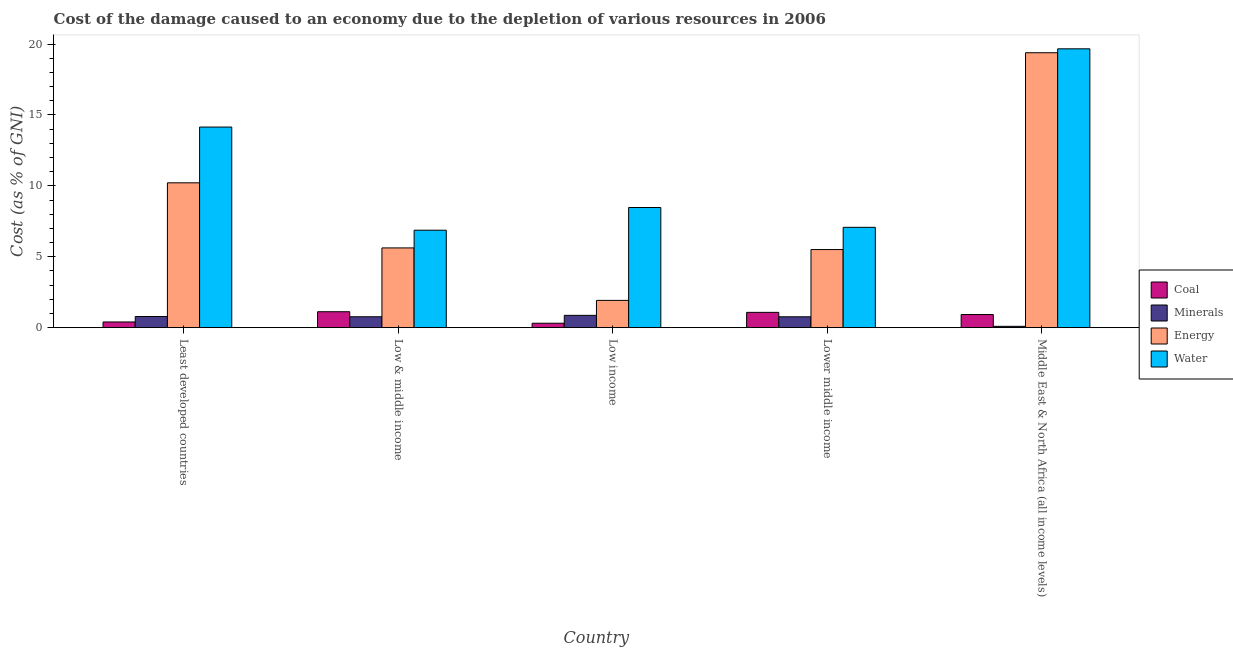How many different coloured bars are there?
Your answer should be compact. 4. How many bars are there on the 4th tick from the left?
Offer a terse response. 4. What is the label of the 4th group of bars from the left?
Your answer should be very brief. Lower middle income. What is the cost of damage due to depletion of energy in Low & middle income?
Keep it short and to the point. 5.62. Across all countries, what is the maximum cost of damage due to depletion of energy?
Your response must be concise. 19.39. Across all countries, what is the minimum cost of damage due to depletion of water?
Give a very brief answer. 6.87. What is the total cost of damage due to depletion of minerals in the graph?
Provide a succinct answer. 3.29. What is the difference between the cost of damage due to depletion of coal in Least developed countries and that in Low income?
Provide a short and direct response. 0.09. What is the difference between the cost of damage due to depletion of energy in Lower middle income and the cost of damage due to depletion of water in Low & middle income?
Give a very brief answer. -1.36. What is the average cost of damage due to depletion of energy per country?
Your response must be concise. 8.53. What is the difference between the cost of damage due to depletion of energy and cost of damage due to depletion of water in Least developed countries?
Your answer should be very brief. -3.93. In how many countries, is the cost of damage due to depletion of minerals greater than 5 %?
Your response must be concise. 0. What is the ratio of the cost of damage due to depletion of water in Lower middle income to that in Middle East & North Africa (all income levels)?
Give a very brief answer. 0.36. What is the difference between the highest and the second highest cost of damage due to depletion of minerals?
Provide a succinct answer. 0.08. What is the difference between the highest and the lowest cost of damage due to depletion of coal?
Your answer should be compact. 0.81. In how many countries, is the cost of damage due to depletion of minerals greater than the average cost of damage due to depletion of minerals taken over all countries?
Provide a succinct answer. 4. What does the 1st bar from the left in Least developed countries represents?
Make the answer very short. Coal. What does the 1st bar from the right in Lower middle income represents?
Your response must be concise. Water. Is it the case that in every country, the sum of the cost of damage due to depletion of coal and cost of damage due to depletion of minerals is greater than the cost of damage due to depletion of energy?
Ensure brevity in your answer.  No. How many countries are there in the graph?
Your answer should be very brief. 5. What is the difference between two consecutive major ticks on the Y-axis?
Offer a very short reply. 5. Does the graph contain any zero values?
Provide a short and direct response. No. Where does the legend appear in the graph?
Your answer should be very brief. Center right. How many legend labels are there?
Provide a short and direct response. 4. How are the legend labels stacked?
Your response must be concise. Vertical. What is the title of the graph?
Provide a short and direct response. Cost of the damage caused to an economy due to the depletion of various resources in 2006 . What is the label or title of the X-axis?
Offer a terse response. Country. What is the label or title of the Y-axis?
Provide a succinct answer. Cost (as % of GNI). What is the Cost (as % of GNI) of Coal in Least developed countries?
Your response must be concise. 0.4. What is the Cost (as % of GNI) in Minerals in Least developed countries?
Offer a very short reply. 0.79. What is the Cost (as % of GNI) in Energy in Least developed countries?
Give a very brief answer. 10.22. What is the Cost (as % of GNI) in Water in Least developed countries?
Give a very brief answer. 14.15. What is the Cost (as % of GNI) in Coal in Low & middle income?
Your answer should be compact. 1.12. What is the Cost (as % of GNI) of Minerals in Low & middle income?
Your response must be concise. 0.77. What is the Cost (as % of GNI) of Energy in Low & middle income?
Offer a terse response. 5.62. What is the Cost (as % of GNI) in Water in Low & middle income?
Keep it short and to the point. 6.87. What is the Cost (as % of GNI) of Coal in Low income?
Offer a terse response. 0.31. What is the Cost (as % of GNI) of Minerals in Low income?
Offer a very short reply. 0.87. What is the Cost (as % of GNI) in Energy in Low income?
Your answer should be very brief. 1.92. What is the Cost (as % of GNI) of Water in Low income?
Offer a terse response. 8.47. What is the Cost (as % of GNI) of Coal in Lower middle income?
Your answer should be compact. 1.08. What is the Cost (as % of GNI) in Minerals in Lower middle income?
Your answer should be compact. 0.77. What is the Cost (as % of GNI) of Energy in Lower middle income?
Your answer should be compact. 5.51. What is the Cost (as % of GNI) of Water in Lower middle income?
Make the answer very short. 7.08. What is the Cost (as % of GNI) in Coal in Middle East & North Africa (all income levels)?
Your response must be concise. 0.93. What is the Cost (as % of GNI) of Minerals in Middle East & North Africa (all income levels)?
Offer a very short reply. 0.09. What is the Cost (as % of GNI) in Energy in Middle East & North Africa (all income levels)?
Offer a terse response. 19.39. What is the Cost (as % of GNI) in Water in Middle East & North Africa (all income levels)?
Provide a short and direct response. 19.67. Across all countries, what is the maximum Cost (as % of GNI) in Coal?
Provide a short and direct response. 1.12. Across all countries, what is the maximum Cost (as % of GNI) of Minerals?
Your answer should be compact. 0.87. Across all countries, what is the maximum Cost (as % of GNI) in Energy?
Ensure brevity in your answer.  19.39. Across all countries, what is the maximum Cost (as % of GNI) in Water?
Your answer should be compact. 19.67. Across all countries, what is the minimum Cost (as % of GNI) of Coal?
Provide a short and direct response. 0.31. Across all countries, what is the minimum Cost (as % of GNI) in Minerals?
Keep it short and to the point. 0.09. Across all countries, what is the minimum Cost (as % of GNI) in Energy?
Your answer should be compact. 1.92. Across all countries, what is the minimum Cost (as % of GNI) of Water?
Give a very brief answer. 6.87. What is the total Cost (as % of GNI) of Coal in the graph?
Provide a succinct answer. 3.84. What is the total Cost (as % of GNI) in Minerals in the graph?
Keep it short and to the point. 3.29. What is the total Cost (as % of GNI) in Energy in the graph?
Your response must be concise. 42.66. What is the total Cost (as % of GNI) in Water in the graph?
Offer a terse response. 56.24. What is the difference between the Cost (as % of GNI) in Coal in Least developed countries and that in Low & middle income?
Provide a succinct answer. -0.72. What is the difference between the Cost (as % of GNI) of Minerals in Least developed countries and that in Low & middle income?
Offer a terse response. 0.02. What is the difference between the Cost (as % of GNI) in Energy in Least developed countries and that in Low & middle income?
Provide a short and direct response. 4.59. What is the difference between the Cost (as % of GNI) in Water in Least developed countries and that in Low & middle income?
Give a very brief answer. 7.27. What is the difference between the Cost (as % of GNI) in Coal in Least developed countries and that in Low income?
Make the answer very short. 0.09. What is the difference between the Cost (as % of GNI) of Minerals in Least developed countries and that in Low income?
Your response must be concise. -0.08. What is the difference between the Cost (as % of GNI) in Energy in Least developed countries and that in Low income?
Your answer should be very brief. 8.29. What is the difference between the Cost (as % of GNI) of Water in Least developed countries and that in Low income?
Your response must be concise. 5.67. What is the difference between the Cost (as % of GNI) of Coal in Least developed countries and that in Lower middle income?
Your answer should be very brief. -0.68. What is the difference between the Cost (as % of GNI) in Minerals in Least developed countries and that in Lower middle income?
Your answer should be very brief. 0.02. What is the difference between the Cost (as % of GNI) of Energy in Least developed countries and that in Lower middle income?
Ensure brevity in your answer.  4.71. What is the difference between the Cost (as % of GNI) of Water in Least developed countries and that in Lower middle income?
Your answer should be compact. 7.07. What is the difference between the Cost (as % of GNI) of Coal in Least developed countries and that in Middle East & North Africa (all income levels)?
Ensure brevity in your answer.  -0.52. What is the difference between the Cost (as % of GNI) of Minerals in Least developed countries and that in Middle East & North Africa (all income levels)?
Make the answer very short. 0.69. What is the difference between the Cost (as % of GNI) of Energy in Least developed countries and that in Middle East & North Africa (all income levels)?
Offer a very short reply. -9.17. What is the difference between the Cost (as % of GNI) of Water in Least developed countries and that in Middle East & North Africa (all income levels)?
Your response must be concise. -5.52. What is the difference between the Cost (as % of GNI) of Coal in Low & middle income and that in Low income?
Your answer should be compact. 0.81. What is the difference between the Cost (as % of GNI) in Minerals in Low & middle income and that in Low income?
Your answer should be compact. -0.1. What is the difference between the Cost (as % of GNI) of Energy in Low & middle income and that in Low income?
Give a very brief answer. 3.7. What is the difference between the Cost (as % of GNI) of Water in Low & middle income and that in Low income?
Your response must be concise. -1.6. What is the difference between the Cost (as % of GNI) of Coal in Low & middle income and that in Lower middle income?
Offer a very short reply. 0.05. What is the difference between the Cost (as % of GNI) in Minerals in Low & middle income and that in Lower middle income?
Your answer should be compact. 0. What is the difference between the Cost (as % of GNI) of Energy in Low & middle income and that in Lower middle income?
Offer a very short reply. 0.11. What is the difference between the Cost (as % of GNI) of Water in Low & middle income and that in Lower middle income?
Your answer should be compact. -0.2. What is the difference between the Cost (as % of GNI) in Coal in Low & middle income and that in Middle East & North Africa (all income levels)?
Keep it short and to the point. 0.2. What is the difference between the Cost (as % of GNI) of Minerals in Low & middle income and that in Middle East & North Africa (all income levels)?
Your answer should be very brief. 0.68. What is the difference between the Cost (as % of GNI) in Energy in Low & middle income and that in Middle East & North Africa (all income levels)?
Ensure brevity in your answer.  -13.77. What is the difference between the Cost (as % of GNI) of Water in Low & middle income and that in Middle East & North Africa (all income levels)?
Give a very brief answer. -12.79. What is the difference between the Cost (as % of GNI) in Coal in Low income and that in Lower middle income?
Offer a terse response. -0.77. What is the difference between the Cost (as % of GNI) in Minerals in Low income and that in Lower middle income?
Offer a very short reply. 0.1. What is the difference between the Cost (as % of GNI) of Energy in Low income and that in Lower middle income?
Keep it short and to the point. -3.59. What is the difference between the Cost (as % of GNI) in Water in Low income and that in Lower middle income?
Your response must be concise. 1.4. What is the difference between the Cost (as % of GNI) in Coal in Low income and that in Middle East & North Africa (all income levels)?
Your answer should be very brief. -0.61. What is the difference between the Cost (as % of GNI) in Minerals in Low income and that in Middle East & North Africa (all income levels)?
Ensure brevity in your answer.  0.77. What is the difference between the Cost (as % of GNI) of Energy in Low income and that in Middle East & North Africa (all income levels)?
Offer a very short reply. -17.47. What is the difference between the Cost (as % of GNI) in Water in Low income and that in Middle East & North Africa (all income levels)?
Your answer should be very brief. -11.19. What is the difference between the Cost (as % of GNI) of Coal in Lower middle income and that in Middle East & North Africa (all income levels)?
Give a very brief answer. 0.15. What is the difference between the Cost (as % of GNI) of Minerals in Lower middle income and that in Middle East & North Africa (all income levels)?
Provide a short and direct response. 0.67. What is the difference between the Cost (as % of GNI) of Energy in Lower middle income and that in Middle East & North Africa (all income levels)?
Your answer should be very brief. -13.88. What is the difference between the Cost (as % of GNI) in Water in Lower middle income and that in Middle East & North Africa (all income levels)?
Ensure brevity in your answer.  -12.59. What is the difference between the Cost (as % of GNI) of Coal in Least developed countries and the Cost (as % of GNI) of Minerals in Low & middle income?
Your answer should be compact. -0.37. What is the difference between the Cost (as % of GNI) in Coal in Least developed countries and the Cost (as % of GNI) in Energy in Low & middle income?
Give a very brief answer. -5.22. What is the difference between the Cost (as % of GNI) of Coal in Least developed countries and the Cost (as % of GNI) of Water in Low & middle income?
Your answer should be very brief. -6.47. What is the difference between the Cost (as % of GNI) in Minerals in Least developed countries and the Cost (as % of GNI) in Energy in Low & middle income?
Keep it short and to the point. -4.84. What is the difference between the Cost (as % of GNI) of Minerals in Least developed countries and the Cost (as % of GNI) of Water in Low & middle income?
Your answer should be very brief. -6.09. What is the difference between the Cost (as % of GNI) in Energy in Least developed countries and the Cost (as % of GNI) in Water in Low & middle income?
Keep it short and to the point. 3.34. What is the difference between the Cost (as % of GNI) of Coal in Least developed countries and the Cost (as % of GNI) of Minerals in Low income?
Ensure brevity in your answer.  -0.47. What is the difference between the Cost (as % of GNI) in Coal in Least developed countries and the Cost (as % of GNI) in Energy in Low income?
Provide a short and direct response. -1.52. What is the difference between the Cost (as % of GNI) in Coal in Least developed countries and the Cost (as % of GNI) in Water in Low income?
Make the answer very short. -8.07. What is the difference between the Cost (as % of GNI) in Minerals in Least developed countries and the Cost (as % of GNI) in Energy in Low income?
Provide a short and direct response. -1.14. What is the difference between the Cost (as % of GNI) of Minerals in Least developed countries and the Cost (as % of GNI) of Water in Low income?
Make the answer very short. -7.69. What is the difference between the Cost (as % of GNI) of Energy in Least developed countries and the Cost (as % of GNI) of Water in Low income?
Your answer should be very brief. 1.74. What is the difference between the Cost (as % of GNI) of Coal in Least developed countries and the Cost (as % of GNI) of Minerals in Lower middle income?
Provide a succinct answer. -0.36. What is the difference between the Cost (as % of GNI) in Coal in Least developed countries and the Cost (as % of GNI) in Energy in Lower middle income?
Keep it short and to the point. -5.11. What is the difference between the Cost (as % of GNI) in Coal in Least developed countries and the Cost (as % of GNI) in Water in Lower middle income?
Ensure brevity in your answer.  -6.67. What is the difference between the Cost (as % of GNI) of Minerals in Least developed countries and the Cost (as % of GNI) of Energy in Lower middle income?
Your response must be concise. -4.72. What is the difference between the Cost (as % of GNI) of Minerals in Least developed countries and the Cost (as % of GNI) of Water in Lower middle income?
Your answer should be very brief. -6.29. What is the difference between the Cost (as % of GNI) in Energy in Least developed countries and the Cost (as % of GNI) in Water in Lower middle income?
Your answer should be very brief. 3.14. What is the difference between the Cost (as % of GNI) of Coal in Least developed countries and the Cost (as % of GNI) of Minerals in Middle East & North Africa (all income levels)?
Offer a terse response. 0.31. What is the difference between the Cost (as % of GNI) in Coal in Least developed countries and the Cost (as % of GNI) in Energy in Middle East & North Africa (all income levels)?
Your response must be concise. -18.99. What is the difference between the Cost (as % of GNI) in Coal in Least developed countries and the Cost (as % of GNI) in Water in Middle East & North Africa (all income levels)?
Provide a succinct answer. -19.26. What is the difference between the Cost (as % of GNI) of Minerals in Least developed countries and the Cost (as % of GNI) of Energy in Middle East & North Africa (all income levels)?
Your answer should be very brief. -18.6. What is the difference between the Cost (as % of GNI) in Minerals in Least developed countries and the Cost (as % of GNI) in Water in Middle East & North Africa (all income levels)?
Provide a succinct answer. -18.88. What is the difference between the Cost (as % of GNI) in Energy in Least developed countries and the Cost (as % of GNI) in Water in Middle East & North Africa (all income levels)?
Provide a succinct answer. -9.45. What is the difference between the Cost (as % of GNI) of Coal in Low & middle income and the Cost (as % of GNI) of Minerals in Low income?
Provide a succinct answer. 0.26. What is the difference between the Cost (as % of GNI) of Coal in Low & middle income and the Cost (as % of GNI) of Energy in Low income?
Provide a succinct answer. -0.8. What is the difference between the Cost (as % of GNI) of Coal in Low & middle income and the Cost (as % of GNI) of Water in Low income?
Your response must be concise. -7.35. What is the difference between the Cost (as % of GNI) of Minerals in Low & middle income and the Cost (as % of GNI) of Energy in Low income?
Provide a succinct answer. -1.15. What is the difference between the Cost (as % of GNI) in Minerals in Low & middle income and the Cost (as % of GNI) in Water in Low income?
Provide a succinct answer. -7.7. What is the difference between the Cost (as % of GNI) in Energy in Low & middle income and the Cost (as % of GNI) in Water in Low income?
Make the answer very short. -2.85. What is the difference between the Cost (as % of GNI) in Coal in Low & middle income and the Cost (as % of GNI) in Minerals in Lower middle income?
Provide a short and direct response. 0.36. What is the difference between the Cost (as % of GNI) in Coal in Low & middle income and the Cost (as % of GNI) in Energy in Lower middle income?
Your answer should be very brief. -4.38. What is the difference between the Cost (as % of GNI) in Coal in Low & middle income and the Cost (as % of GNI) in Water in Lower middle income?
Your answer should be compact. -5.95. What is the difference between the Cost (as % of GNI) of Minerals in Low & middle income and the Cost (as % of GNI) of Energy in Lower middle income?
Provide a short and direct response. -4.74. What is the difference between the Cost (as % of GNI) in Minerals in Low & middle income and the Cost (as % of GNI) in Water in Lower middle income?
Keep it short and to the point. -6.31. What is the difference between the Cost (as % of GNI) in Energy in Low & middle income and the Cost (as % of GNI) in Water in Lower middle income?
Offer a very short reply. -1.45. What is the difference between the Cost (as % of GNI) in Coal in Low & middle income and the Cost (as % of GNI) in Minerals in Middle East & North Africa (all income levels)?
Provide a short and direct response. 1.03. What is the difference between the Cost (as % of GNI) in Coal in Low & middle income and the Cost (as % of GNI) in Energy in Middle East & North Africa (all income levels)?
Offer a terse response. -18.27. What is the difference between the Cost (as % of GNI) of Coal in Low & middle income and the Cost (as % of GNI) of Water in Middle East & North Africa (all income levels)?
Give a very brief answer. -18.54. What is the difference between the Cost (as % of GNI) in Minerals in Low & middle income and the Cost (as % of GNI) in Energy in Middle East & North Africa (all income levels)?
Keep it short and to the point. -18.62. What is the difference between the Cost (as % of GNI) of Minerals in Low & middle income and the Cost (as % of GNI) of Water in Middle East & North Africa (all income levels)?
Make the answer very short. -18.9. What is the difference between the Cost (as % of GNI) of Energy in Low & middle income and the Cost (as % of GNI) of Water in Middle East & North Africa (all income levels)?
Provide a short and direct response. -14.04. What is the difference between the Cost (as % of GNI) in Coal in Low income and the Cost (as % of GNI) in Minerals in Lower middle income?
Your answer should be compact. -0.45. What is the difference between the Cost (as % of GNI) of Coal in Low income and the Cost (as % of GNI) of Energy in Lower middle income?
Your answer should be compact. -5.2. What is the difference between the Cost (as % of GNI) of Coal in Low income and the Cost (as % of GNI) of Water in Lower middle income?
Provide a short and direct response. -6.76. What is the difference between the Cost (as % of GNI) of Minerals in Low income and the Cost (as % of GNI) of Energy in Lower middle income?
Your answer should be compact. -4.64. What is the difference between the Cost (as % of GNI) of Minerals in Low income and the Cost (as % of GNI) of Water in Lower middle income?
Ensure brevity in your answer.  -6.21. What is the difference between the Cost (as % of GNI) of Energy in Low income and the Cost (as % of GNI) of Water in Lower middle income?
Ensure brevity in your answer.  -5.15. What is the difference between the Cost (as % of GNI) in Coal in Low income and the Cost (as % of GNI) in Minerals in Middle East & North Africa (all income levels)?
Your response must be concise. 0.22. What is the difference between the Cost (as % of GNI) in Coal in Low income and the Cost (as % of GNI) in Energy in Middle East & North Africa (all income levels)?
Provide a succinct answer. -19.08. What is the difference between the Cost (as % of GNI) in Coal in Low income and the Cost (as % of GNI) in Water in Middle East & North Africa (all income levels)?
Your answer should be compact. -19.35. What is the difference between the Cost (as % of GNI) in Minerals in Low income and the Cost (as % of GNI) in Energy in Middle East & North Africa (all income levels)?
Offer a very short reply. -18.52. What is the difference between the Cost (as % of GNI) in Minerals in Low income and the Cost (as % of GNI) in Water in Middle East & North Africa (all income levels)?
Keep it short and to the point. -18.8. What is the difference between the Cost (as % of GNI) in Energy in Low income and the Cost (as % of GNI) in Water in Middle East & North Africa (all income levels)?
Your answer should be very brief. -17.74. What is the difference between the Cost (as % of GNI) in Coal in Lower middle income and the Cost (as % of GNI) in Minerals in Middle East & North Africa (all income levels)?
Your answer should be compact. 0.98. What is the difference between the Cost (as % of GNI) in Coal in Lower middle income and the Cost (as % of GNI) in Energy in Middle East & North Africa (all income levels)?
Offer a very short reply. -18.31. What is the difference between the Cost (as % of GNI) in Coal in Lower middle income and the Cost (as % of GNI) in Water in Middle East & North Africa (all income levels)?
Provide a succinct answer. -18.59. What is the difference between the Cost (as % of GNI) in Minerals in Lower middle income and the Cost (as % of GNI) in Energy in Middle East & North Africa (all income levels)?
Offer a very short reply. -18.62. What is the difference between the Cost (as % of GNI) in Minerals in Lower middle income and the Cost (as % of GNI) in Water in Middle East & North Africa (all income levels)?
Your answer should be very brief. -18.9. What is the difference between the Cost (as % of GNI) in Energy in Lower middle income and the Cost (as % of GNI) in Water in Middle East & North Africa (all income levels)?
Give a very brief answer. -14.16. What is the average Cost (as % of GNI) in Coal per country?
Your answer should be compact. 0.77. What is the average Cost (as % of GNI) in Minerals per country?
Ensure brevity in your answer.  0.66. What is the average Cost (as % of GNI) in Energy per country?
Your answer should be compact. 8.53. What is the average Cost (as % of GNI) of Water per country?
Provide a succinct answer. 11.25. What is the difference between the Cost (as % of GNI) in Coal and Cost (as % of GNI) in Minerals in Least developed countries?
Offer a very short reply. -0.38. What is the difference between the Cost (as % of GNI) in Coal and Cost (as % of GNI) in Energy in Least developed countries?
Offer a very short reply. -9.81. What is the difference between the Cost (as % of GNI) of Coal and Cost (as % of GNI) of Water in Least developed countries?
Provide a succinct answer. -13.75. What is the difference between the Cost (as % of GNI) in Minerals and Cost (as % of GNI) in Energy in Least developed countries?
Your answer should be compact. -9.43. What is the difference between the Cost (as % of GNI) of Minerals and Cost (as % of GNI) of Water in Least developed countries?
Make the answer very short. -13.36. What is the difference between the Cost (as % of GNI) in Energy and Cost (as % of GNI) in Water in Least developed countries?
Ensure brevity in your answer.  -3.93. What is the difference between the Cost (as % of GNI) in Coal and Cost (as % of GNI) in Minerals in Low & middle income?
Your response must be concise. 0.35. What is the difference between the Cost (as % of GNI) of Coal and Cost (as % of GNI) of Energy in Low & middle income?
Provide a succinct answer. -4.5. What is the difference between the Cost (as % of GNI) in Coal and Cost (as % of GNI) in Water in Low & middle income?
Make the answer very short. -5.75. What is the difference between the Cost (as % of GNI) in Minerals and Cost (as % of GNI) in Energy in Low & middle income?
Keep it short and to the point. -4.85. What is the difference between the Cost (as % of GNI) in Minerals and Cost (as % of GNI) in Water in Low & middle income?
Provide a succinct answer. -6.1. What is the difference between the Cost (as % of GNI) in Energy and Cost (as % of GNI) in Water in Low & middle income?
Ensure brevity in your answer.  -1.25. What is the difference between the Cost (as % of GNI) in Coal and Cost (as % of GNI) in Minerals in Low income?
Provide a short and direct response. -0.56. What is the difference between the Cost (as % of GNI) of Coal and Cost (as % of GNI) of Energy in Low income?
Your answer should be compact. -1.61. What is the difference between the Cost (as % of GNI) in Coal and Cost (as % of GNI) in Water in Low income?
Your response must be concise. -8.16. What is the difference between the Cost (as % of GNI) of Minerals and Cost (as % of GNI) of Energy in Low income?
Keep it short and to the point. -1.05. What is the difference between the Cost (as % of GNI) in Minerals and Cost (as % of GNI) in Water in Low income?
Make the answer very short. -7.61. What is the difference between the Cost (as % of GNI) of Energy and Cost (as % of GNI) of Water in Low income?
Give a very brief answer. -6.55. What is the difference between the Cost (as % of GNI) of Coal and Cost (as % of GNI) of Minerals in Lower middle income?
Offer a terse response. 0.31. What is the difference between the Cost (as % of GNI) of Coal and Cost (as % of GNI) of Energy in Lower middle income?
Offer a terse response. -4.43. What is the difference between the Cost (as % of GNI) of Coal and Cost (as % of GNI) of Water in Lower middle income?
Give a very brief answer. -6. What is the difference between the Cost (as % of GNI) of Minerals and Cost (as % of GNI) of Energy in Lower middle income?
Provide a succinct answer. -4.74. What is the difference between the Cost (as % of GNI) of Minerals and Cost (as % of GNI) of Water in Lower middle income?
Offer a terse response. -6.31. What is the difference between the Cost (as % of GNI) in Energy and Cost (as % of GNI) in Water in Lower middle income?
Offer a very short reply. -1.57. What is the difference between the Cost (as % of GNI) in Coal and Cost (as % of GNI) in Minerals in Middle East & North Africa (all income levels)?
Provide a short and direct response. 0.83. What is the difference between the Cost (as % of GNI) of Coal and Cost (as % of GNI) of Energy in Middle East & North Africa (all income levels)?
Keep it short and to the point. -18.46. What is the difference between the Cost (as % of GNI) in Coal and Cost (as % of GNI) in Water in Middle East & North Africa (all income levels)?
Your answer should be very brief. -18.74. What is the difference between the Cost (as % of GNI) of Minerals and Cost (as % of GNI) of Energy in Middle East & North Africa (all income levels)?
Your response must be concise. -19.3. What is the difference between the Cost (as % of GNI) in Minerals and Cost (as % of GNI) in Water in Middle East & North Africa (all income levels)?
Offer a terse response. -19.57. What is the difference between the Cost (as % of GNI) of Energy and Cost (as % of GNI) of Water in Middle East & North Africa (all income levels)?
Your response must be concise. -0.28. What is the ratio of the Cost (as % of GNI) in Coal in Least developed countries to that in Low & middle income?
Make the answer very short. 0.36. What is the ratio of the Cost (as % of GNI) in Minerals in Least developed countries to that in Low & middle income?
Keep it short and to the point. 1.02. What is the ratio of the Cost (as % of GNI) in Energy in Least developed countries to that in Low & middle income?
Your answer should be very brief. 1.82. What is the ratio of the Cost (as % of GNI) in Water in Least developed countries to that in Low & middle income?
Your answer should be compact. 2.06. What is the ratio of the Cost (as % of GNI) of Coal in Least developed countries to that in Low income?
Keep it short and to the point. 1.29. What is the ratio of the Cost (as % of GNI) in Minerals in Least developed countries to that in Low income?
Offer a very short reply. 0.91. What is the ratio of the Cost (as % of GNI) of Energy in Least developed countries to that in Low income?
Your response must be concise. 5.31. What is the ratio of the Cost (as % of GNI) in Water in Least developed countries to that in Low income?
Offer a very short reply. 1.67. What is the ratio of the Cost (as % of GNI) of Coal in Least developed countries to that in Lower middle income?
Your answer should be compact. 0.37. What is the ratio of the Cost (as % of GNI) in Minerals in Least developed countries to that in Lower middle income?
Your answer should be compact. 1.03. What is the ratio of the Cost (as % of GNI) of Energy in Least developed countries to that in Lower middle income?
Give a very brief answer. 1.85. What is the ratio of the Cost (as % of GNI) in Water in Least developed countries to that in Lower middle income?
Provide a short and direct response. 2. What is the ratio of the Cost (as % of GNI) in Coal in Least developed countries to that in Middle East & North Africa (all income levels)?
Your response must be concise. 0.43. What is the ratio of the Cost (as % of GNI) in Minerals in Least developed countries to that in Middle East & North Africa (all income levels)?
Keep it short and to the point. 8.37. What is the ratio of the Cost (as % of GNI) of Energy in Least developed countries to that in Middle East & North Africa (all income levels)?
Offer a very short reply. 0.53. What is the ratio of the Cost (as % of GNI) in Water in Least developed countries to that in Middle East & North Africa (all income levels)?
Ensure brevity in your answer.  0.72. What is the ratio of the Cost (as % of GNI) in Coal in Low & middle income to that in Low income?
Your answer should be compact. 3.6. What is the ratio of the Cost (as % of GNI) of Minerals in Low & middle income to that in Low income?
Your answer should be very brief. 0.89. What is the ratio of the Cost (as % of GNI) in Energy in Low & middle income to that in Low income?
Ensure brevity in your answer.  2.92. What is the ratio of the Cost (as % of GNI) in Water in Low & middle income to that in Low income?
Ensure brevity in your answer.  0.81. What is the ratio of the Cost (as % of GNI) of Coal in Low & middle income to that in Lower middle income?
Provide a short and direct response. 1.04. What is the ratio of the Cost (as % of GNI) of Minerals in Low & middle income to that in Lower middle income?
Provide a short and direct response. 1. What is the ratio of the Cost (as % of GNI) in Energy in Low & middle income to that in Lower middle income?
Provide a succinct answer. 1.02. What is the ratio of the Cost (as % of GNI) of Water in Low & middle income to that in Lower middle income?
Make the answer very short. 0.97. What is the ratio of the Cost (as % of GNI) of Coal in Low & middle income to that in Middle East & North Africa (all income levels)?
Offer a terse response. 1.21. What is the ratio of the Cost (as % of GNI) in Minerals in Low & middle income to that in Middle East & North Africa (all income levels)?
Provide a short and direct response. 8.19. What is the ratio of the Cost (as % of GNI) in Energy in Low & middle income to that in Middle East & North Africa (all income levels)?
Provide a succinct answer. 0.29. What is the ratio of the Cost (as % of GNI) in Water in Low & middle income to that in Middle East & North Africa (all income levels)?
Your response must be concise. 0.35. What is the ratio of the Cost (as % of GNI) of Coal in Low income to that in Lower middle income?
Offer a terse response. 0.29. What is the ratio of the Cost (as % of GNI) of Minerals in Low income to that in Lower middle income?
Make the answer very short. 1.13. What is the ratio of the Cost (as % of GNI) in Energy in Low income to that in Lower middle income?
Your answer should be very brief. 0.35. What is the ratio of the Cost (as % of GNI) in Water in Low income to that in Lower middle income?
Your response must be concise. 1.2. What is the ratio of the Cost (as % of GNI) in Coal in Low income to that in Middle East & North Africa (all income levels)?
Provide a short and direct response. 0.34. What is the ratio of the Cost (as % of GNI) of Minerals in Low income to that in Middle East & North Africa (all income levels)?
Ensure brevity in your answer.  9.25. What is the ratio of the Cost (as % of GNI) in Energy in Low income to that in Middle East & North Africa (all income levels)?
Your response must be concise. 0.1. What is the ratio of the Cost (as % of GNI) in Water in Low income to that in Middle East & North Africa (all income levels)?
Give a very brief answer. 0.43. What is the ratio of the Cost (as % of GNI) of Coal in Lower middle income to that in Middle East & North Africa (all income levels)?
Offer a very short reply. 1.16. What is the ratio of the Cost (as % of GNI) in Minerals in Lower middle income to that in Middle East & North Africa (all income levels)?
Keep it short and to the point. 8.17. What is the ratio of the Cost (as % of GNI) in Energy in Lower middle income to that in Middle East & North Africa (all income levels)?
Make the answer very short. 0.28. What is the ratio of the Cost (as % of GNI) in Water in Lower middle income to that in Middle East & North Africa (all income levels)?
Provide a short and direct response. 0.36. What is the difference between the highest and the second highest Cost (as % of GNI) of Coal?
Keep it short and to the point. 0.05. What is the difference between the highest and the second highest Cost (as % of GNI) of Minerals?
Your answer should be compact. 0.08. What is the difference between the highest and the second highest Cost (as % of GNI) of Energy?
Give a very brief answer. 9.17. What is the difference between the highest and the second highest Cost (as % of GNI) of Water?
Provide a short and direct response. 5.52. What is the difference between the highest and the lowest Cost (as % of GNI) of Coal?
Make the answer very short. 0.81. What is the difference between the highest and the lowest Cost (as % of GNI) in Minerals?
Provide a succinct answer. 0.77. What is the difference between the highest and the lowest Cost (as % of GNI) in Energy?
Ensure brevity in your answer.  17.47. What is the difference between the highest and the lowest Cost (as % of GNI) in Water?
Give a very brief answer. 12.79. 